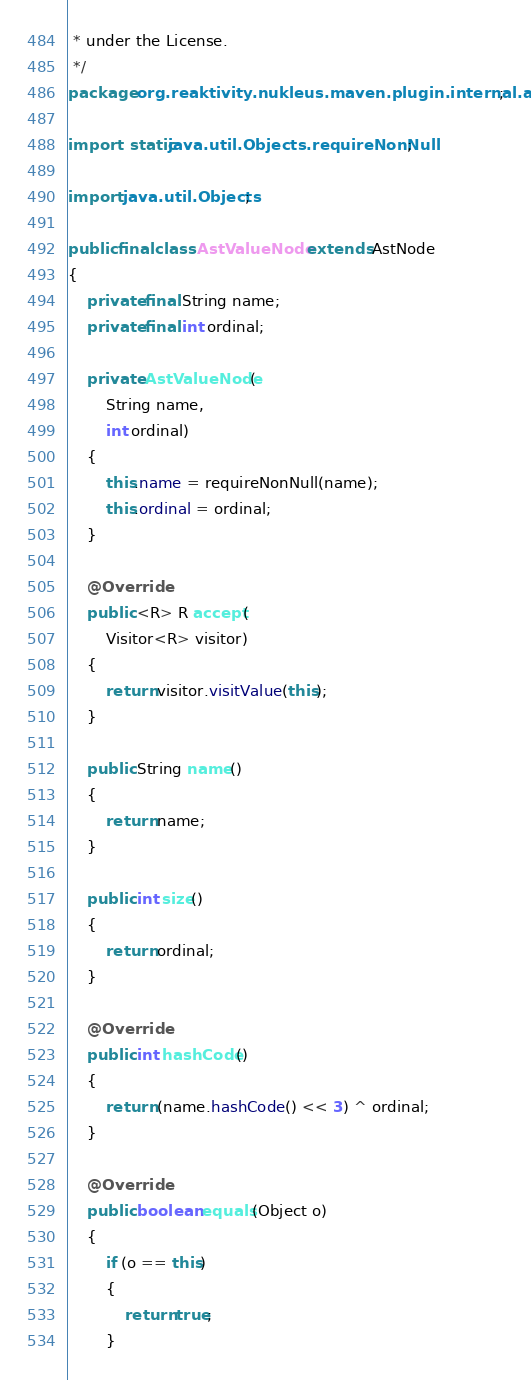Convert code to text. <code><loc_0><loc_0><loc_500><loc_500><_Java_> * under the License.
 */
package org.reaktivity.nukleus.maven.plugin.internal.ast;

import static java.util.Objects.requireNonNull;

import java.util.Objects;

public final class AstValueNode extends AstNode
{
    private final String name;
    private final int ordinal;

    private AstValueNode(
        String name,
        int ordinal)
    {
        this.name = requireNonNull(name);
        this.ordinal = ordinal;
    }

    @Override
    public <R> R accept(
        Visitor<R> visitor)
    {
        return visitor.visitValue(this);
    }

    public String name()
    {
        return name;
    }

    public int size()
    {
        return ordinal;
    }

    @Override
    public int hashCode()
    {
        return (name.hashCode() << 3) ^ ordinal;
    }

    @Override
    public boolean equals(Object o)
    {
        if (o == this)
        {
            return true;
        }
</code> 